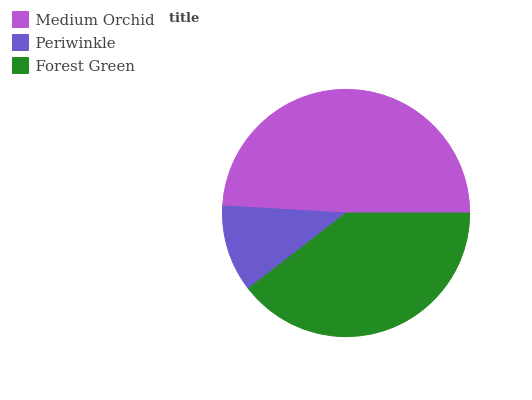Is Periwinkle the minimum?
Answer yes or no. Yes. Is Medium Orchid the maximum?
Answer yes or no. Yes. Is Forest Green the minimum?
Answer yes or no. No. Is Forest Green the maximum?
Answer yes or no. No. Is Forest Green greater than Periwinkle?
Answer yes or no. Yes. Is Periwinkle less than Forest Green?
Answer yes or no. Yes. Is Periwinkle greater than Forest Green?
Answer yes or no. No. Is Forest Green less than Periwinkle?
Answer yes or no. No. Is Forest Green the high median?
Answer yes or no. Yes. Is Forest Green the low median?
Answer yes or no. Yes. Is Medium Orchid the high median?
Answer yes or no. No. Is Periwinkle the low median?
Answer yes or no. No. 